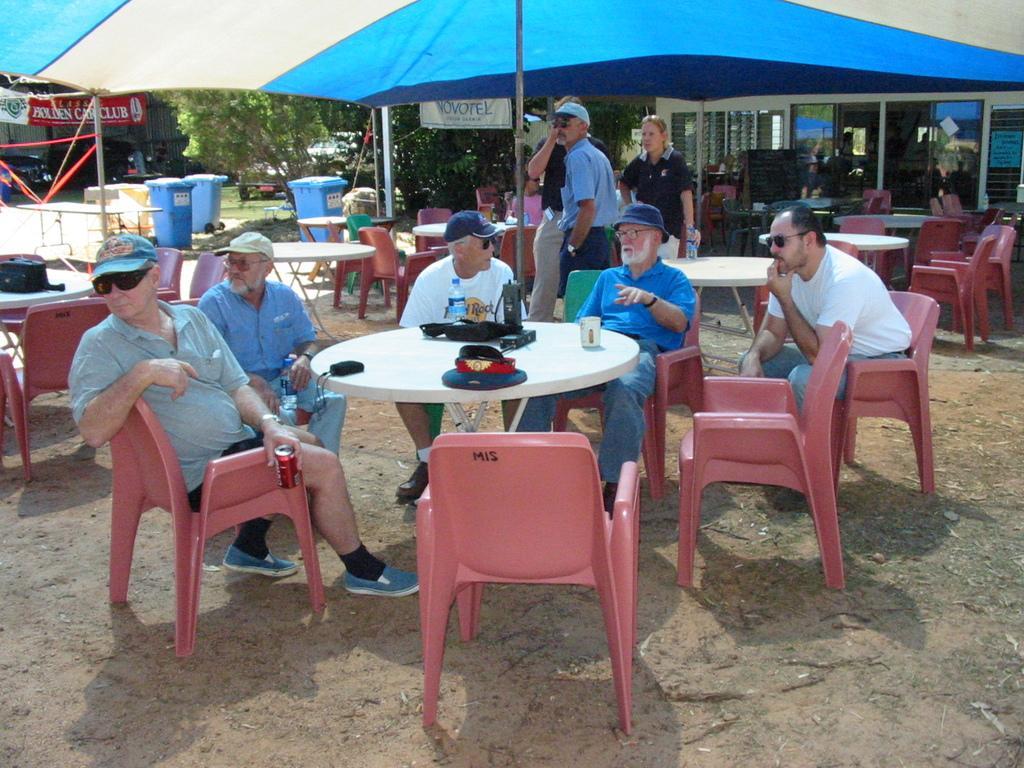Could you give a brief overview of what you see in this image? In this image we can see this people are sitting on the chairs around a table. In the background we can see tables and chairs, persons standing, trash cans, umbrellas, trees, cars, house and banners. 